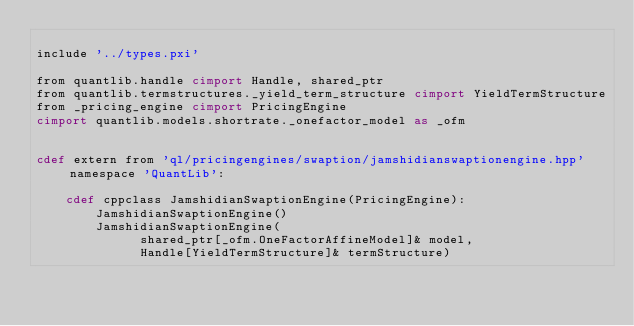<code> <loc_0><loc_0><loc_500><loc_500><_Cython_>
include '../types.pxi'

from quantlib.handle cimport Handle, shared_ptr
from quantlib.termstructures._yield_term_structure cimport YieldTermStructure
from _pricing_engine cimport PricingEngine
cimport quantlib.models.shortrate._onefactor_model as _ofm


cdef extern from 'ql/pricingengines/swaption/jamshidianswaptionengine.hpp' namespace 'QuantLib':

    cdef cppclass JamshidianSwaptionEngine(PricingEngine):
        JamshidianSwaptionEngine()
        JamshidianSwaptionEngine(
              shared_ptr[_ofm.OneFactorAffineModel]& model,
              Handle[YieldTermStructure]& termStructure)
</code> 